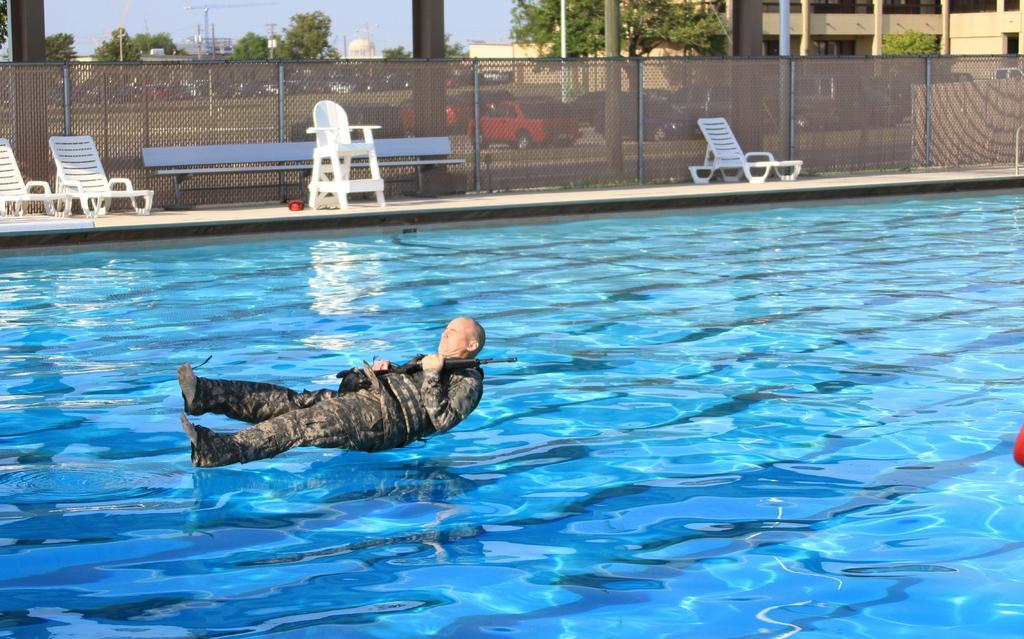Can you describe this image briefly? At the bottom of the image there is a swimming pool. Behind the pool on the floor there are chairs and benches. Behind them there is fencing. Behind the fencing there are cars on the ground and also there are trees, poles and buildings with walls and pillars. And also there is sky in the background. 